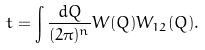<formula> <loc_0><loc_0><loc_500><loc_500>t = \int \frac { d { Q } } { ( 2 \pi ) ^ { n } } W ( { Q } ) W _ { 1 2 } ( { Q } ) .</formula> 